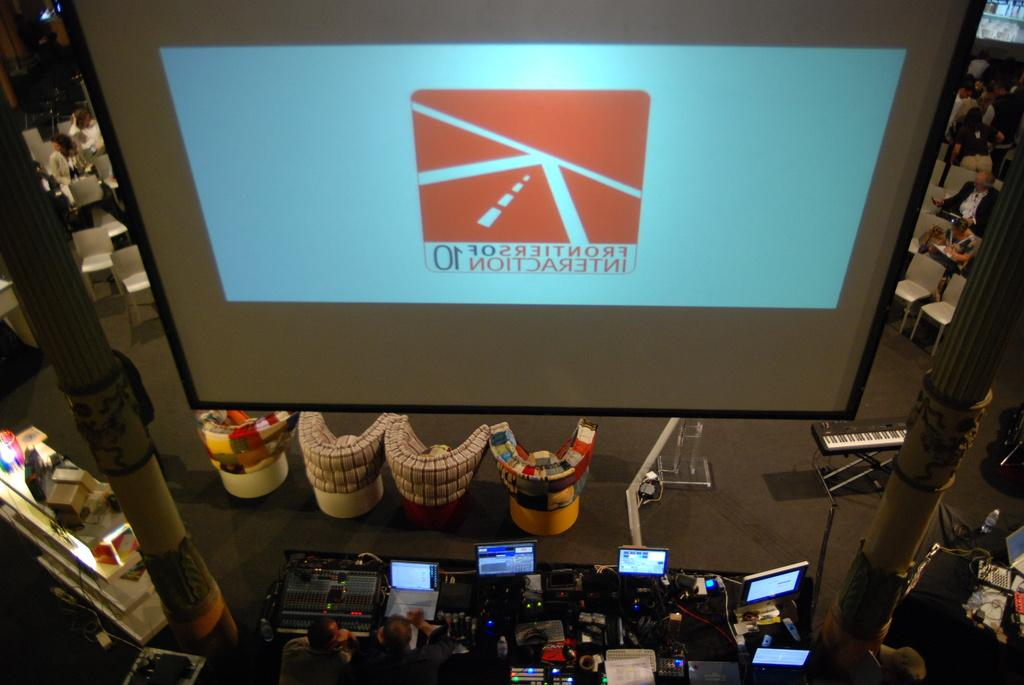<image>
Create a compact narrative representing the image presented. Frontiers Interaction has a presentation planned for the audience. 